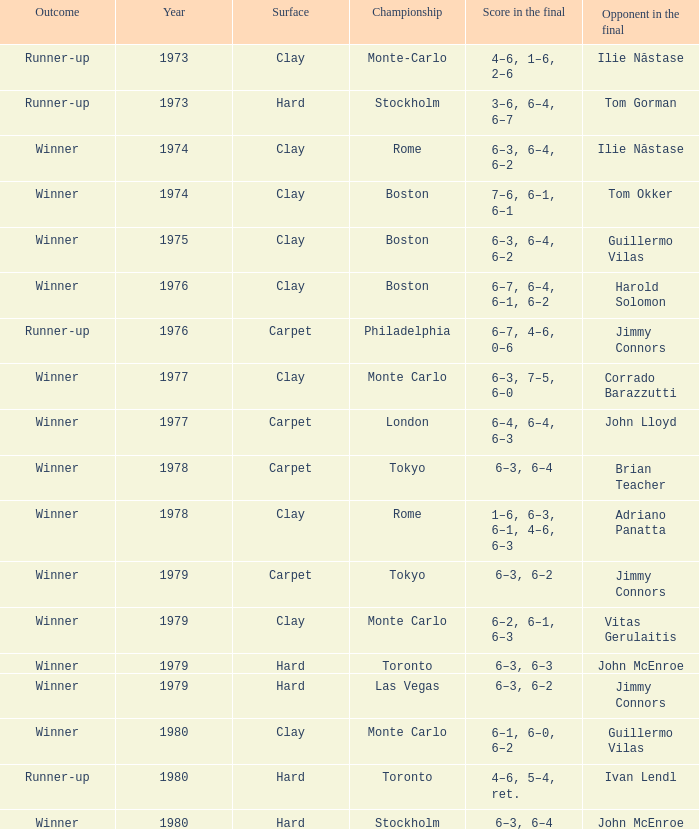Name the total number of opponent in the final for 6–2, 6–1, 6–3 1.0. 